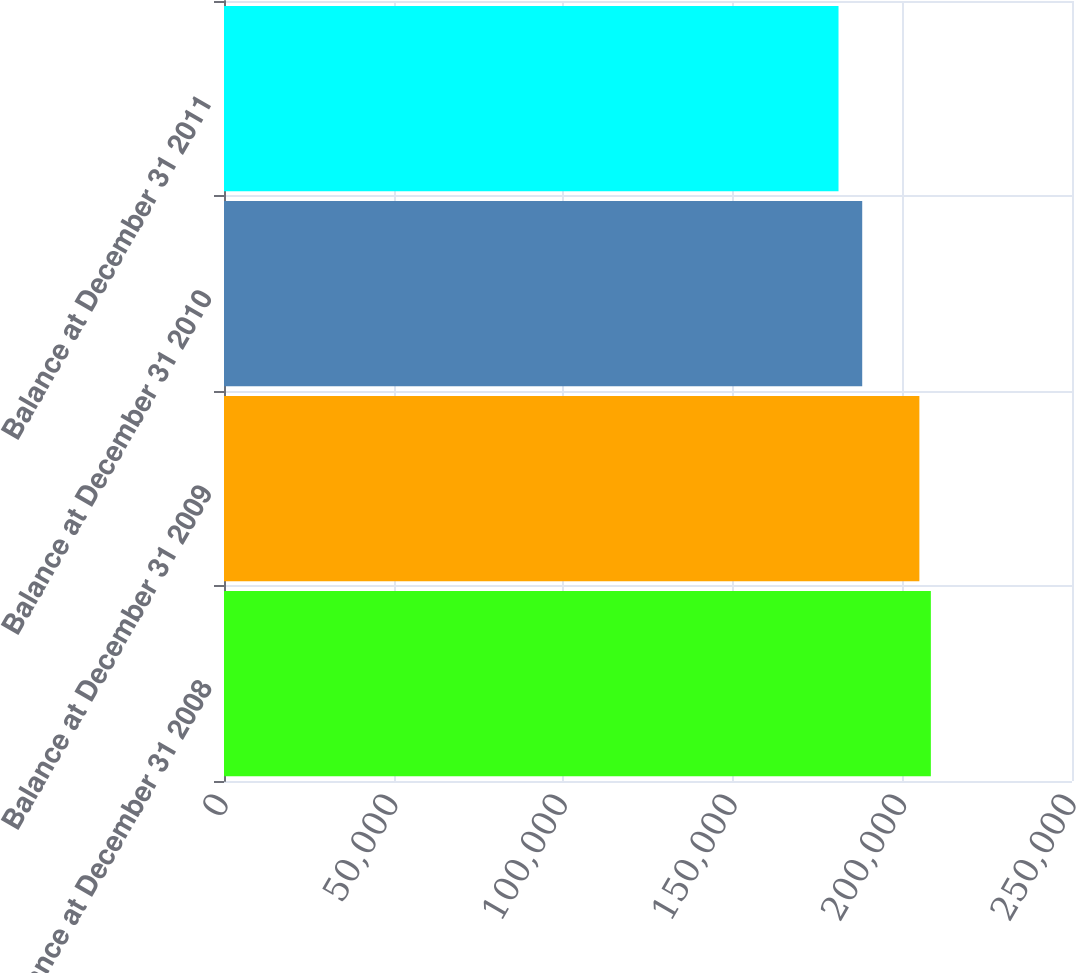Convert chart. <chart><loc_0><loc_0><loc_500><loc_500><bar_chart><fcel>Balance at December 31 2008<fcel>Balance at December 31 2009<fcel>Balance at December 31 2010<fcel>Balance at December 31 2011<nl><fcel>208391<fcel>205005<fcel>188154<fcel>181165<nl></chart> 